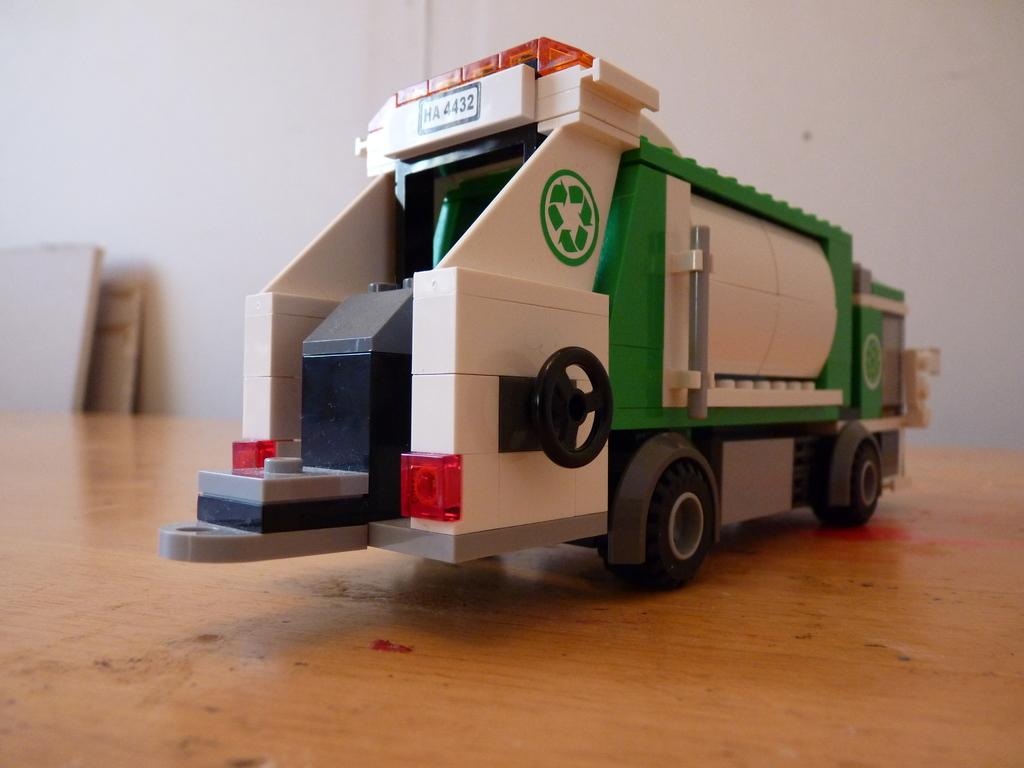What type of toy is in the image? There is a plastic truck in the image. Where is the plastic truck located? The plastic truck is on a table. What else can be seen in the image besides the plastic truck? There are boards near a wall in the image. What type of sail can be seen on the beach in the image? There is no sail or beach present in the image; it features a plastic truck on a table and boards near a wall. 